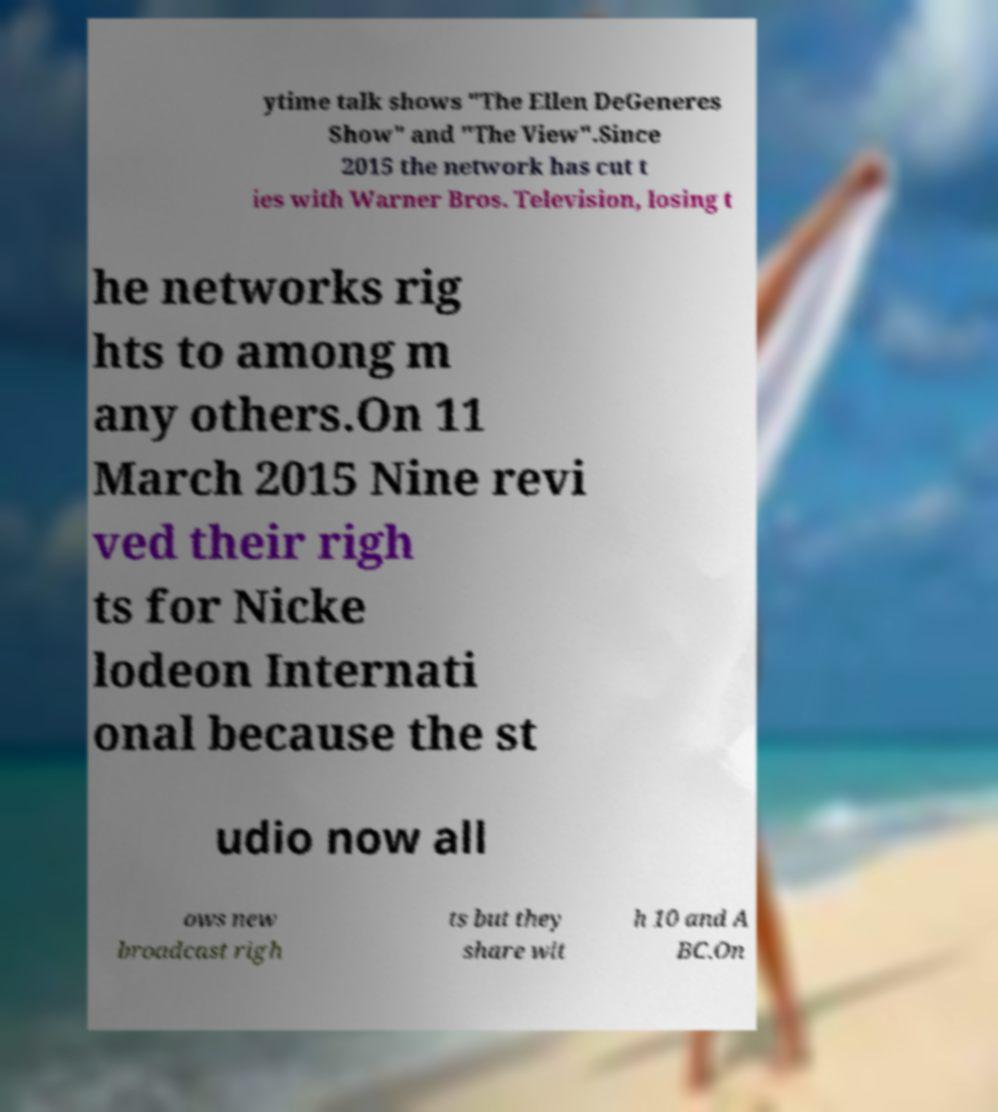Please read and relay the text visible in this image. What does it say? ytime talk shows "The Ellen DeGeneres Show" and "The View".Since 2015 the network has cut t ies with Warner Bros. Television, losing t he networks rig hts to among m any others.On 11 March 2015 Nine revi ved their righ ts for Nicke lodeon Internati onal because the st udio now all ows new broadcast righ ts but they share wit h 10 and A BC.On 